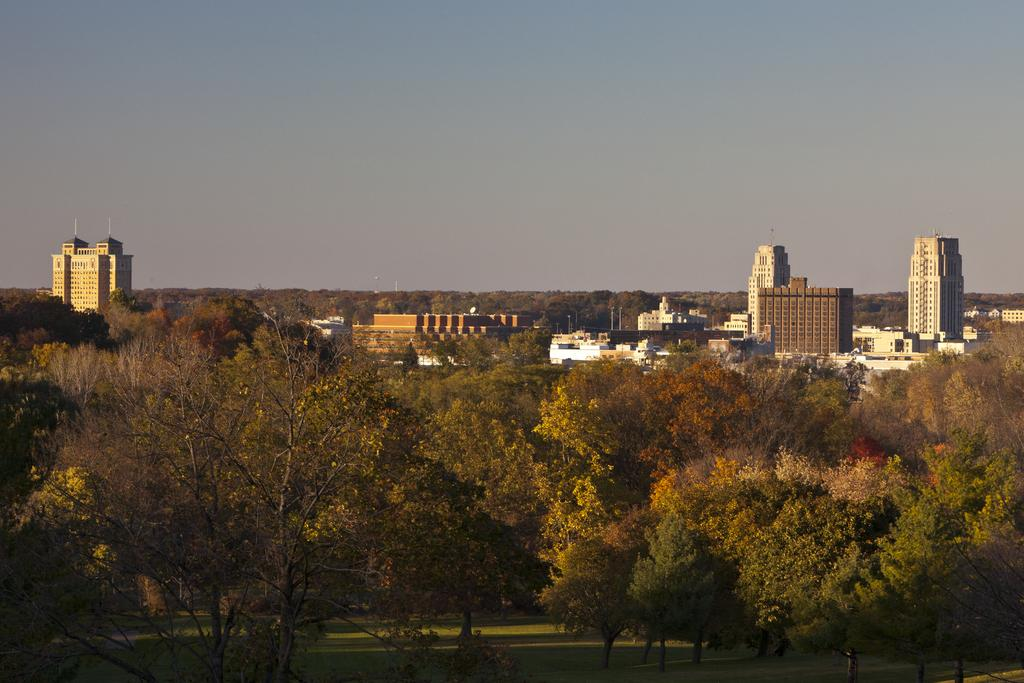What is located in the center of the image? There are buildings in the center of the image. What type of vegetation can be seen in the image? Trees are present in the image. What part of the natural environment is visible at the bottom of the image? The ground is visible at the bottom of the image. What is visible at the top of the image? The sky is visible at the top of the image. What type of pickle is hanging from the trees in the image? There are no pickles present in the image; it features buildings, trees, ground, and sky. Can you tell me how many flies are buzzing around the buildings in the image? There is no mention of flies in the image; it only features buildings, trees, ground, and sky. 